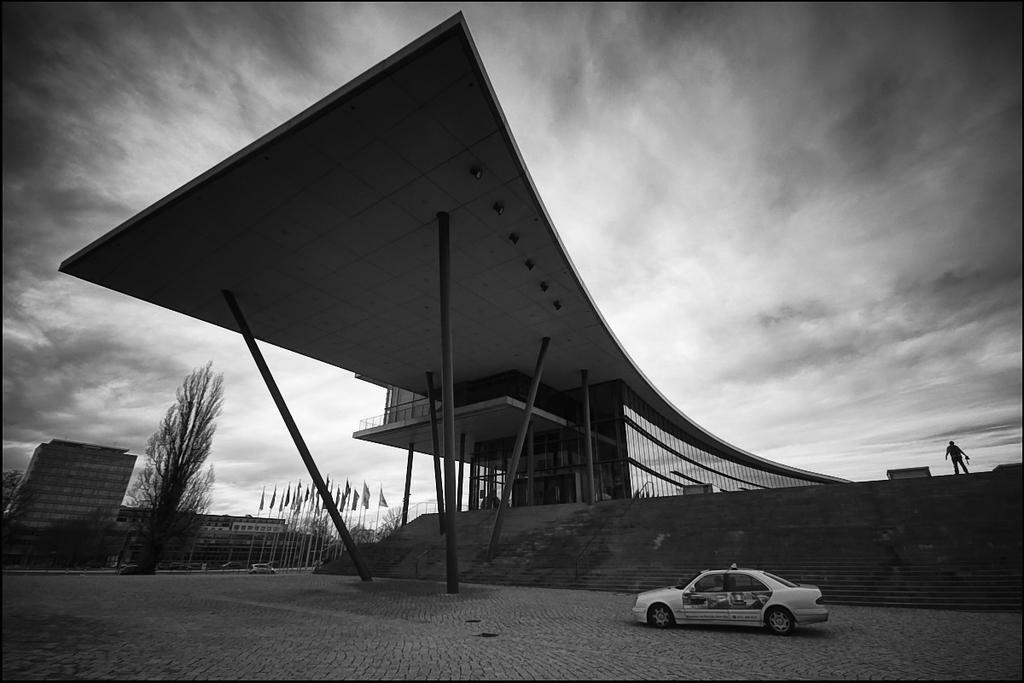Describe this image in one or two sentences. In this image I can see few buildings, trees, few flags, poles and vehicles. The image is in black and white. 